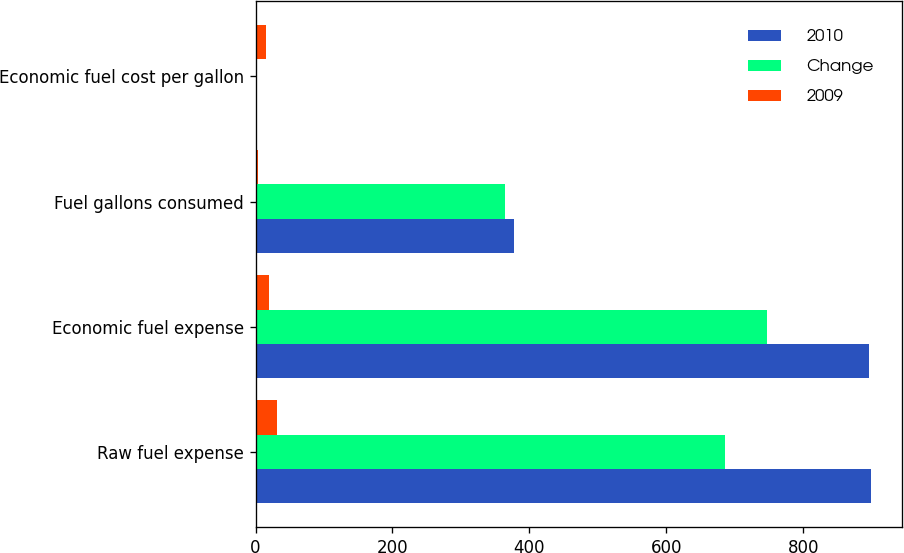Convert chart to OTSL. <chart><loc_0><loc_0><loc_500><loc_500><stacked_bar_chart><ecel><fcel>Raw fuel expense<fcel>Economic fuel expense<fcel>Fuel gallons consumed<fcel>Economic fuel cost per gallon<nl><fcel>2010<fcel>898.9<fcel>895.6<fcel>377.3<fcel>2.37<nl><fcel>Change<fcel>686.2<fcel>746.9<fcel>365<fcel>2.05<nl><fcel>2009<fcel>31<fcel>19.9<fcel>3.4<fcel>15.6<nl></chart> 